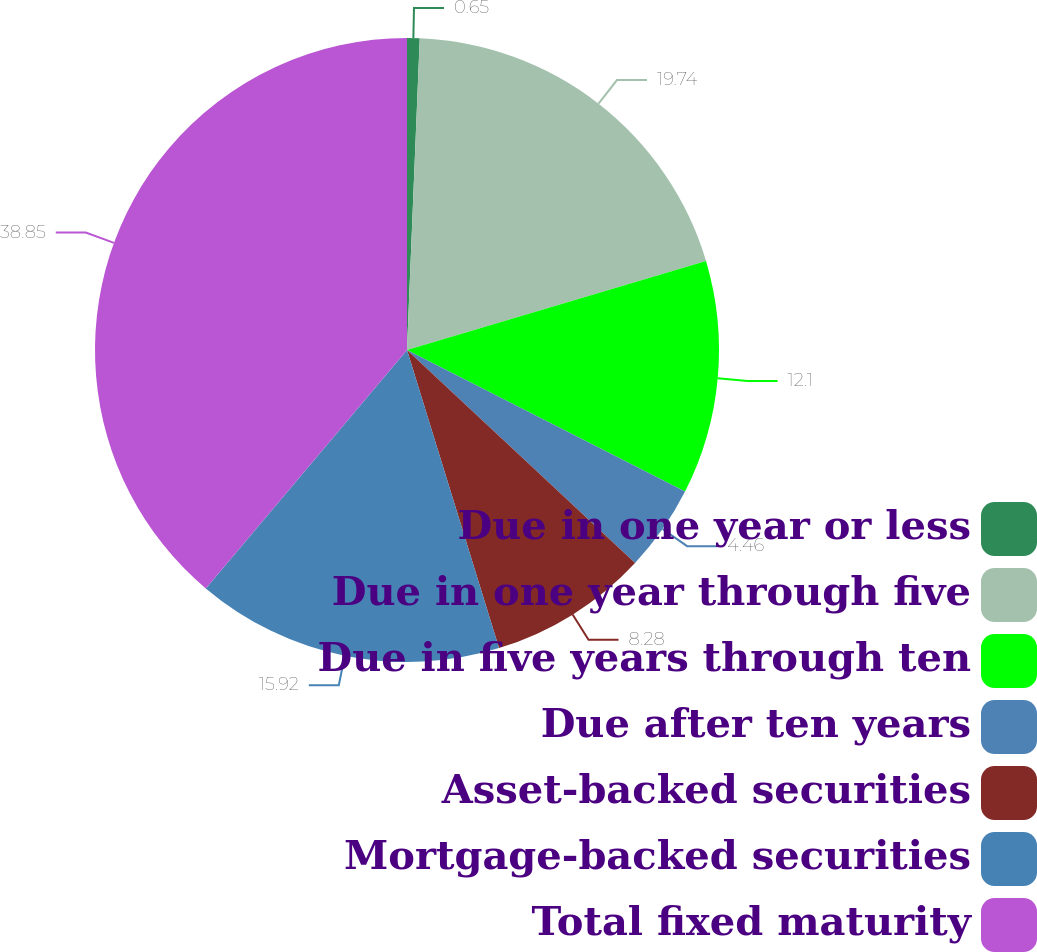<chart> <loc_0><loc_0><loc_500><loc_500><pie_chart><fcel>Due in one year or less<fcel>Due in one year through five<fcel>Due in five years through ten<fcel>Due after ten years<fcel>Asset-backed securities<fcel>Mortgage-backed securities<fcel>Total fixed maturity<nl><fcel>0.65%<fcel>19.74%<fcel>12.1%<fcel>4.46%<fcel>8.28%<fcel>15.92%<fcel>38.84%<nl></chart> 